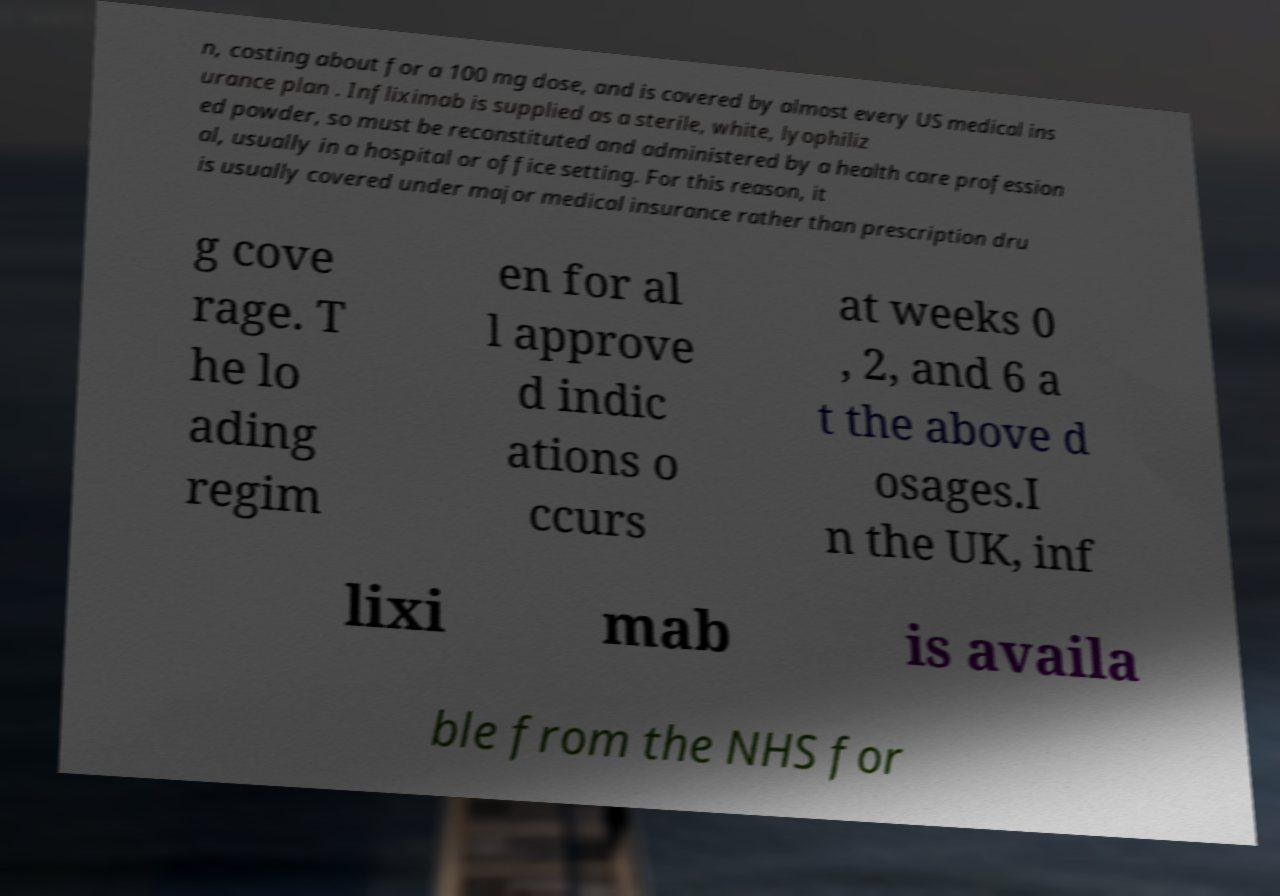For documentation purposes, I need the text within this image transcribed. Could you provide that? n, costing about for a 100 mg dose, and is covered by almost every US medical ins urance plan . Infliximab is supplied as a sterile, white, lyophiliz ed powder, so must be reconstituted and administered by a health care profession al, usually in a hospital or office setting. For this reason, it is usually covered under major medical insurance rather than prescription dru g cove rage. T he lo ading regim en for al l approve d indic ations o ccurs at weeks 0 , 2, and 6 a t the above d osages.I n the UK, inf lixi mab is availa ble from the NHS for 